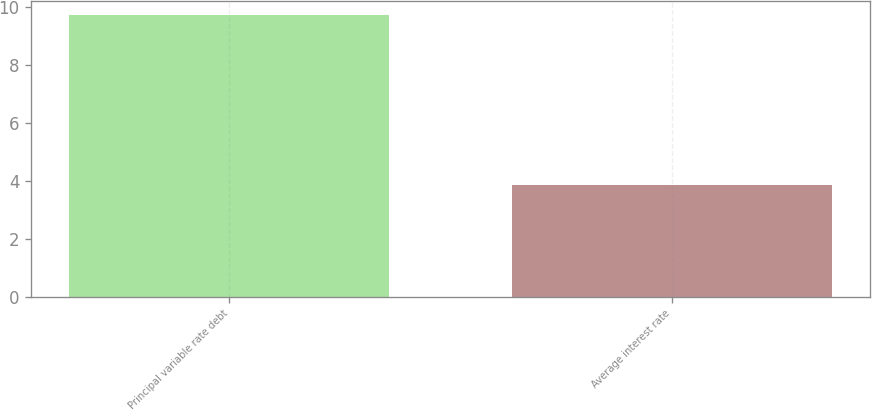<chart> <loc_0><loc_0><loc_500><loc_500><bar_chart><fcel>Principal variable rate debt<fcel>Average interest rate<nl><fcel>9.7<fcel>3.86<nl></chart> 